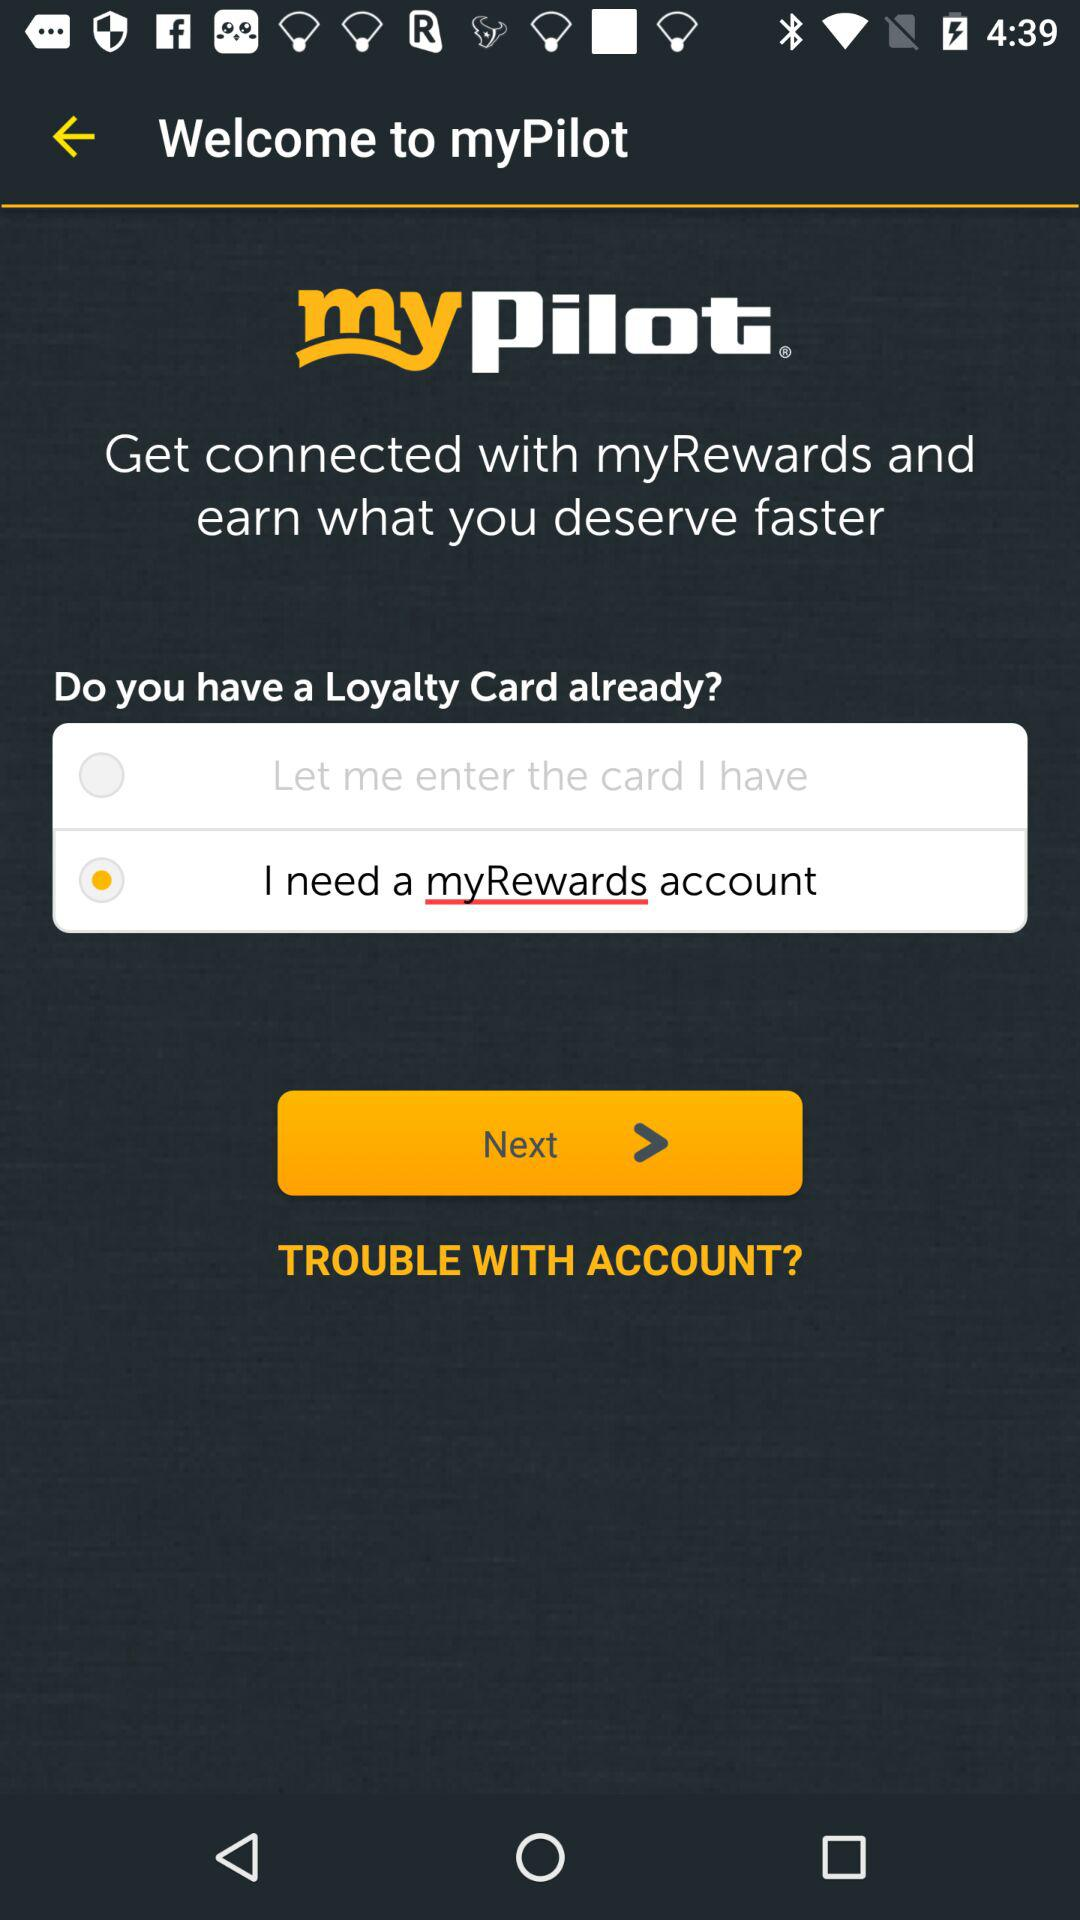What is the name of the application? The name of the application is "mypilot". 